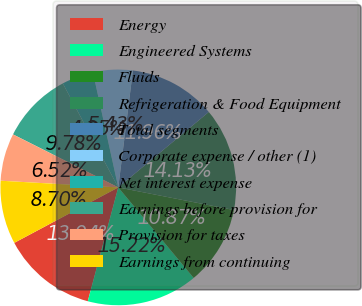<chart> <loc_0><loc_0><loc_500><loc_500><pie_chart><fcel>Energy<fcel>Engineered Systems<fcel>Fluids<fcel>Refrigeration & Food Equipment<fcel>Total segments<fcel>Corporate expense / other (1)<fcel>Net interest expense<fcel>Earnings before provision for<fcel>Provision for taxes<fcel>Earnings from continuing<nl><fcel>13.04%<fcel>15.22%<fcel>10.87%<fcel>14.13%<fcel>11.96%<fcel>5.43%<fcel>4.35%<fcel>9.78%<fcel>6.52%<fcel>8.7%<nl></chart> 